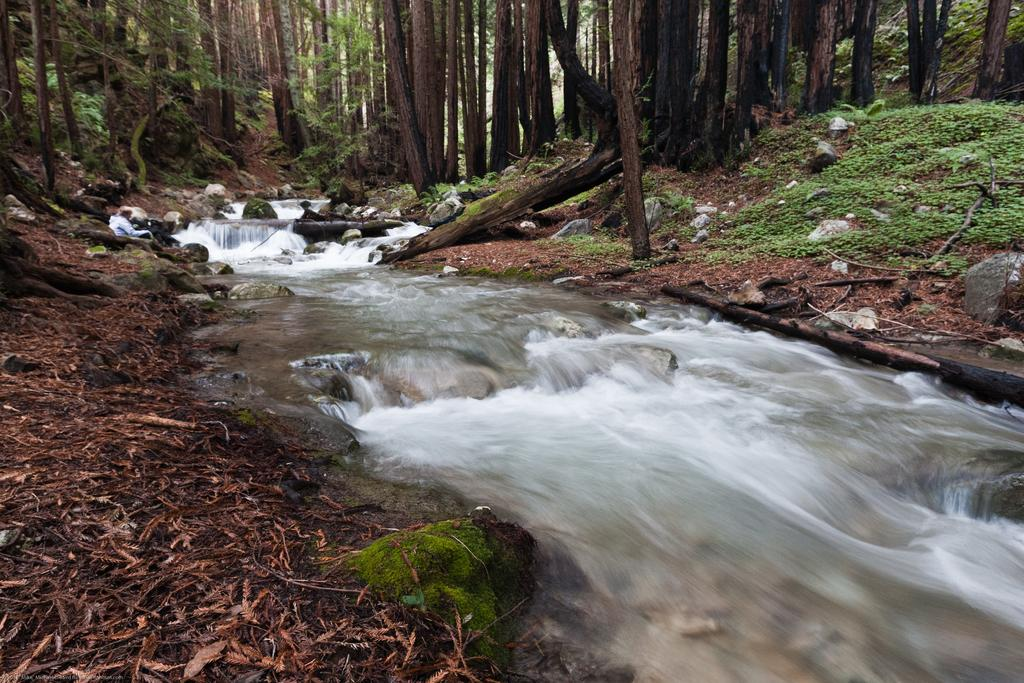What is the primary element visible in the image? There is water in the image. What type of vegetation can be seen in the image? There are trees in the image. What type of bread is visible in the image? There is no bread present in the image. How many knots are tied in the trees in the image? There are no knots visible in the trees in the image. 